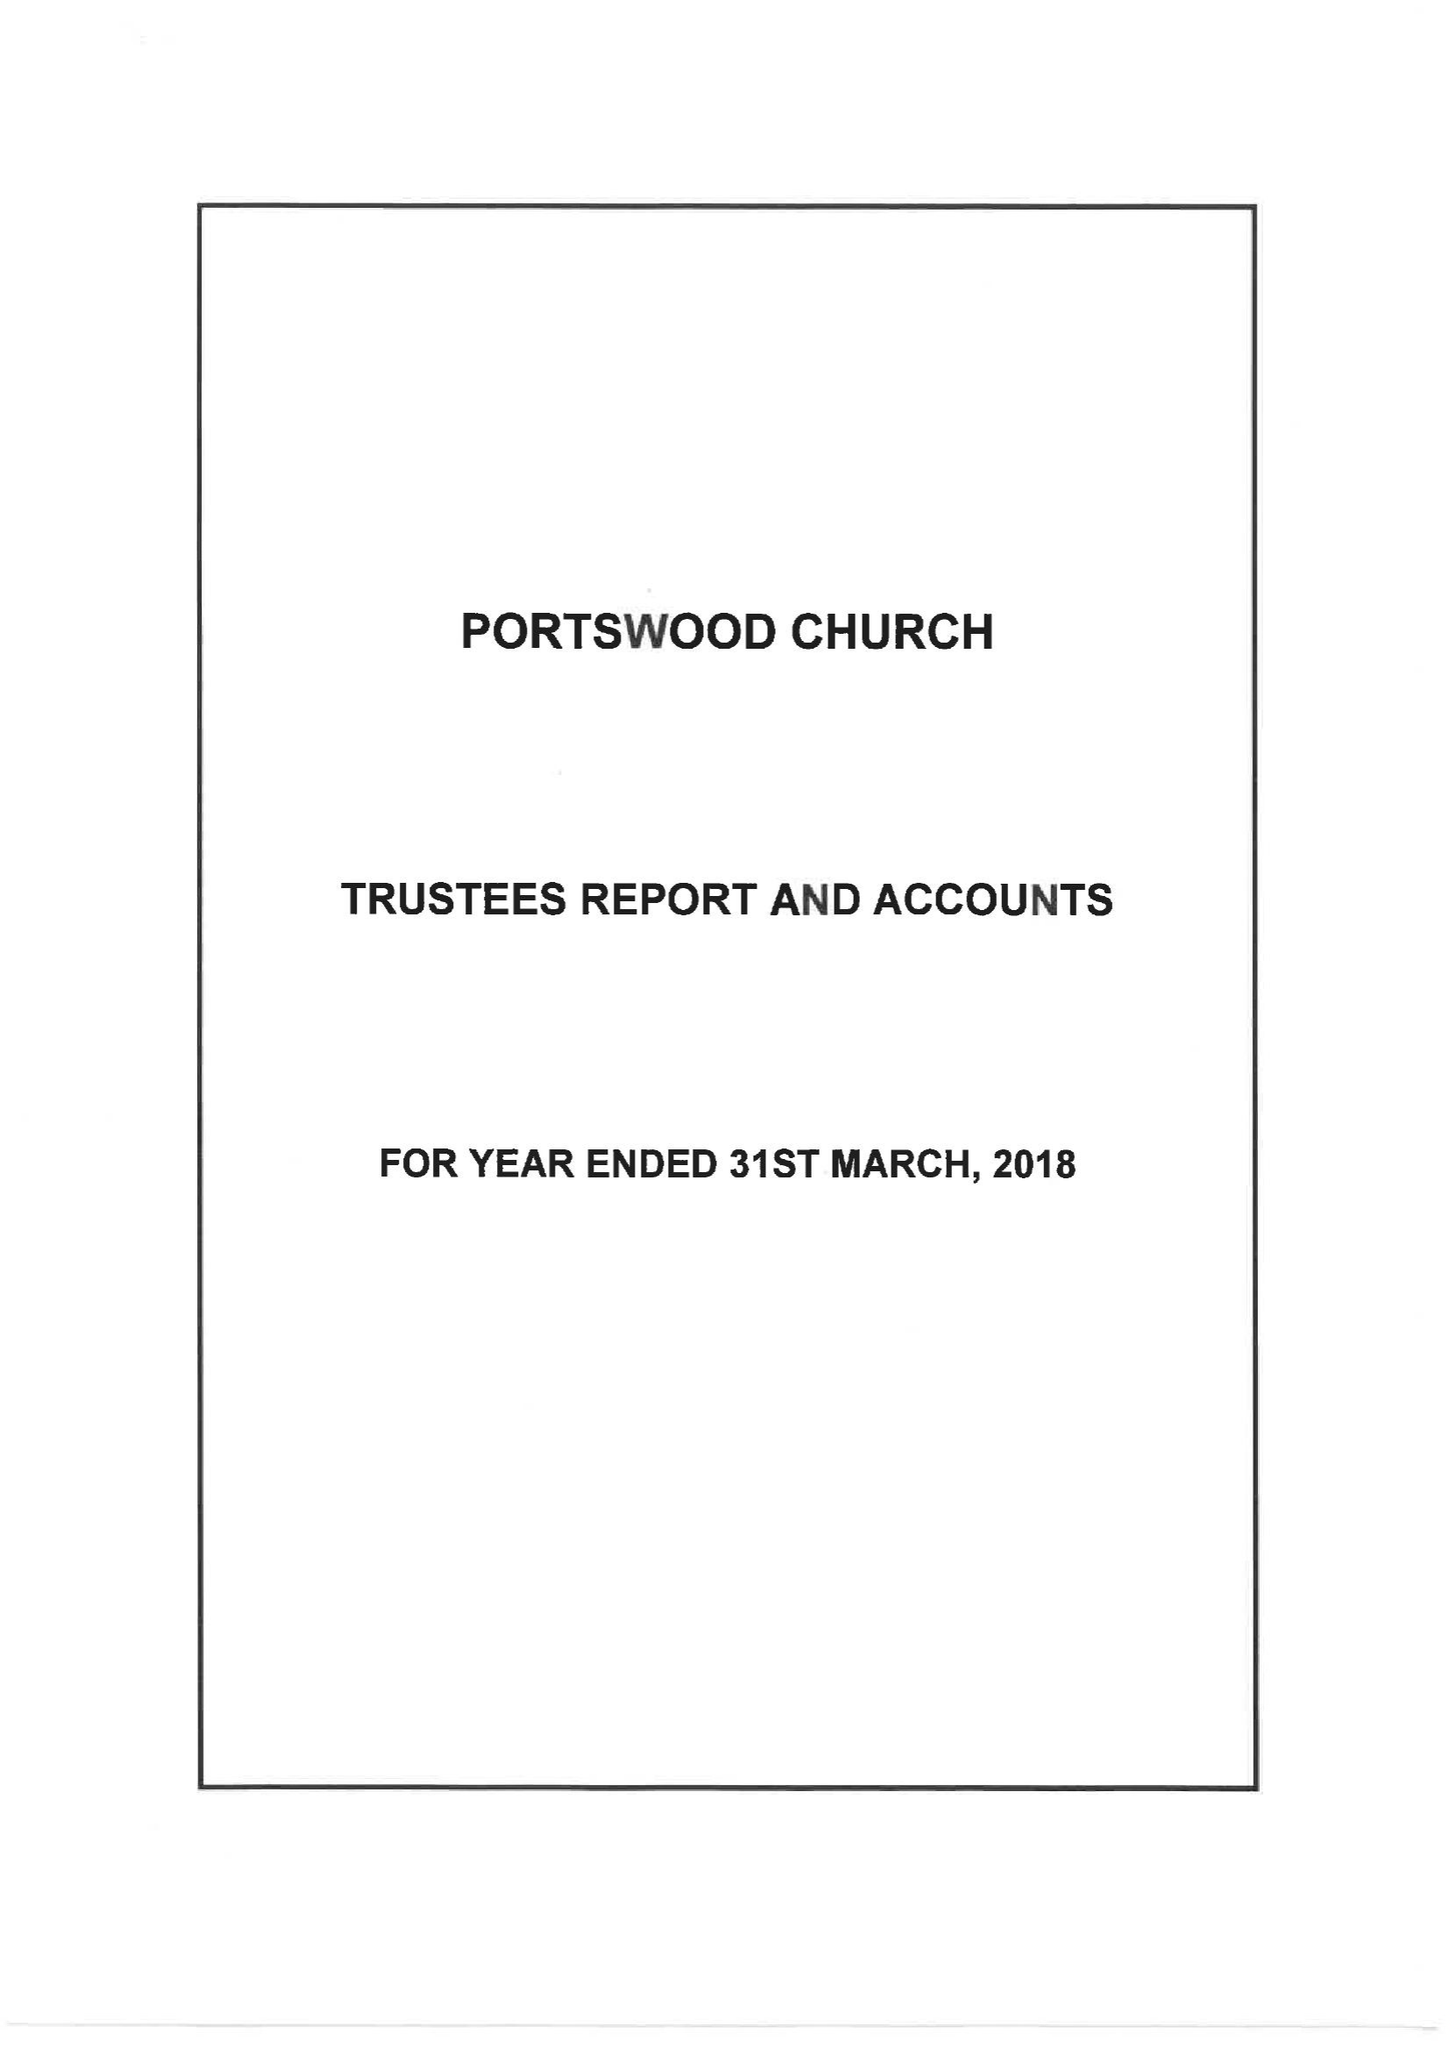What is the value for the report_date?
Answer the question using a single word or phrase. 2018-03-31 